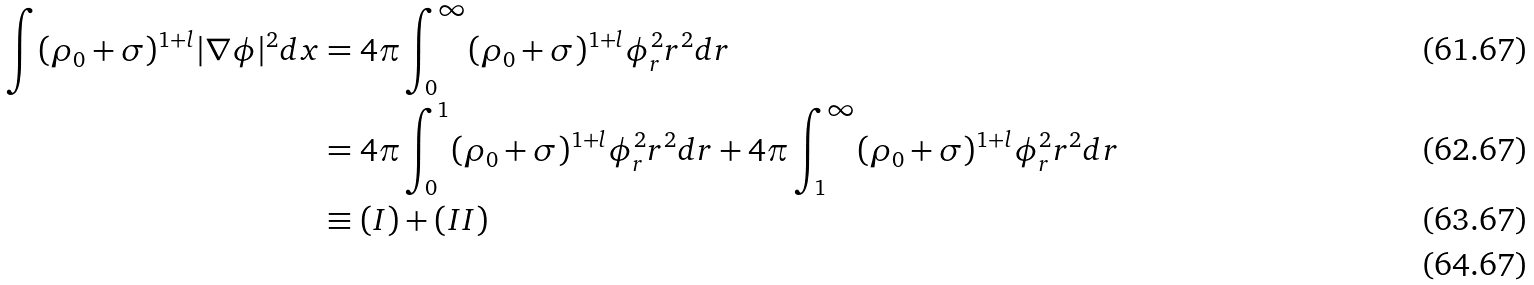<formula> <loc_0><loc_0><loc_500><loc_500>\int ( \rho _ { 0 } + \sigma ) ^ { 1 + l } | \nabla \phi | ^ { 2 } d x & = 4 \pi \int _ { 0 } ^ { \infty } ( \rho _ { 0 } + \sigma ) ^ { 1 + l } \phi _ { r } ^ { 2 } r ^ { 2 } d r \\ & = 4 \pi \int _ { 0 } ^ { 1 } ( \rho _ { 0 } + \sigma ) ^ { 1 + l } \phi _ { r } ^ { 2 } r ^ { 2 } d r + 4 \pi \int _ { 1 } ^ { \infty } ( \rho _ { 0 } + \sigma ) ^ { 1 + l } \phi _ { r } ^ { 2 } r ^ { 2 } d r \\ & \equiv ( I ) + ( I I ) \\</formula> 